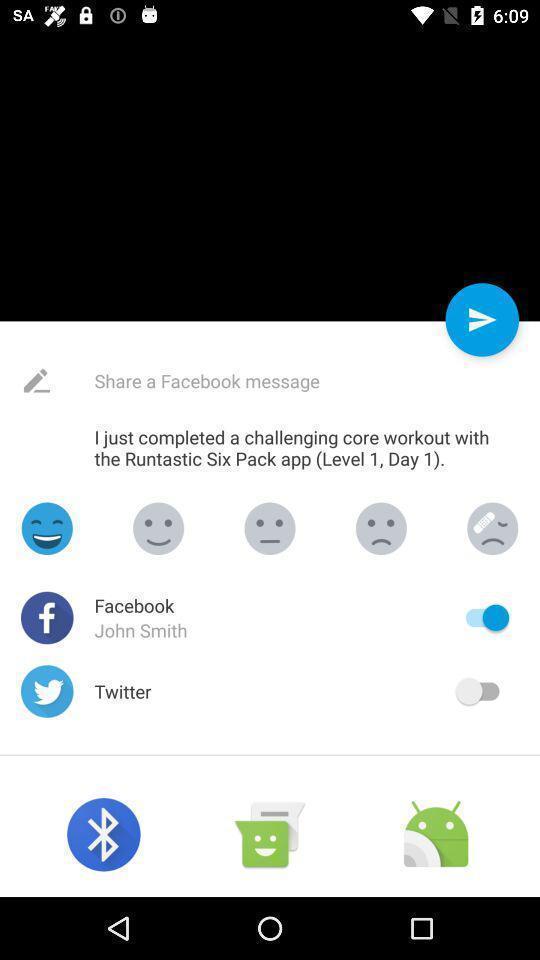Describe the visual elements of this screenshot. Pop-up showing different applications to share. 